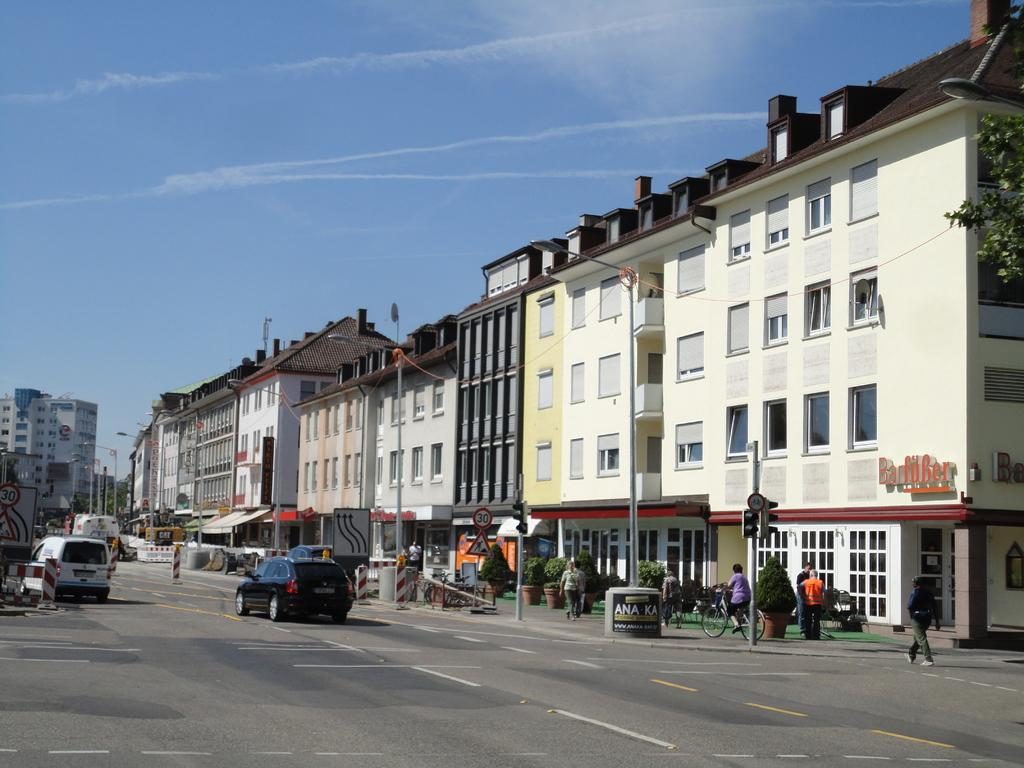How many people are present in the image? There is a group of people in the image, but the exact number cannot be determined from the provided facts. What can be seen on the road in the image? There are vehicles on the road in the image. What are the poles in the image used for? The purpose of the poles in the image cannot be determined from the provided facts. What type of lights are present in the image? There are lights in the image, but their specific type cannot be determined from the provided facts. What information can be found on the sign boards in the image? The information on the sign boards in the image cannot be determined from the provided facts. What type of structures are visible in the image? There are buildings in the image, but their specific type cannot be determined from the provided facts. What type of vegetation is present in the image? There are trees in the image. Where is the scarecrow located in the image? There is no scarecrow present in the image. What type of sport is being played in the image? There is no indication of any sport being played in the image. 